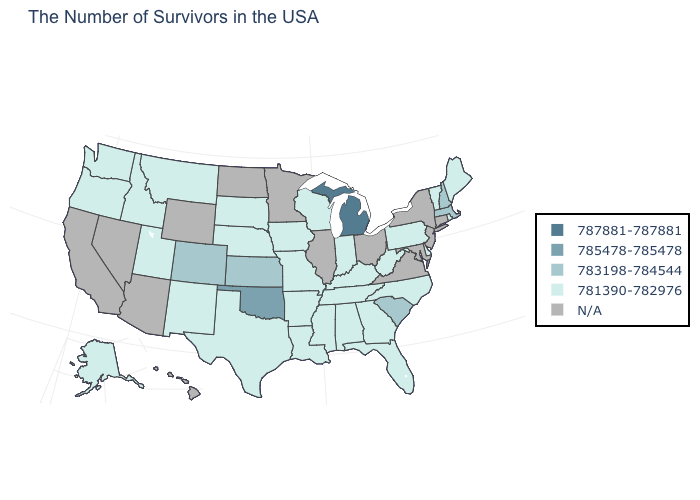Does Michigan have the highest value in the MidWest?
Quick response, please. Yes. How many symbols are there in the legend?
Write a very short answer. 5. What is the value of North Dakota?
Quick response, please. N/A. Name the states that have a value in the range 787881-787881?
Write a very short answer. Michigan. What is the value of Virginia?
Write a very short answer. N/A. What is the lowest value in the USA?
Answer briefly. 781390-782976. Does the map have missing data?
Answer briefly. Yes. How many symbols are there in the legend?
Write a very short answer. 5. What is the value of Massachusetts?
Keep it brief. 783198-784544. Name the states that have a value in the range 781390-782976?
Keep it brief. Maine, Rhode Island, Vermont, Delaware, Pennsylvania, North Carolina, West Virginia, Florida, Georgia, Kentucky, Indiana, Alabama, Tennessee, Wisconsin, Mississippi, Louisiana, Missouri, Arkansas, Iowa, Nebraska, Texas, South Dakota, New Mexico, Utah, Montana, Idaho, Washington, Oregon, Alaska. How many symbols are there in the legend?
Answer briefly. 5. Name the states that have a value in the range 785478-785478?
Write a very short answer. Oklahoma. 